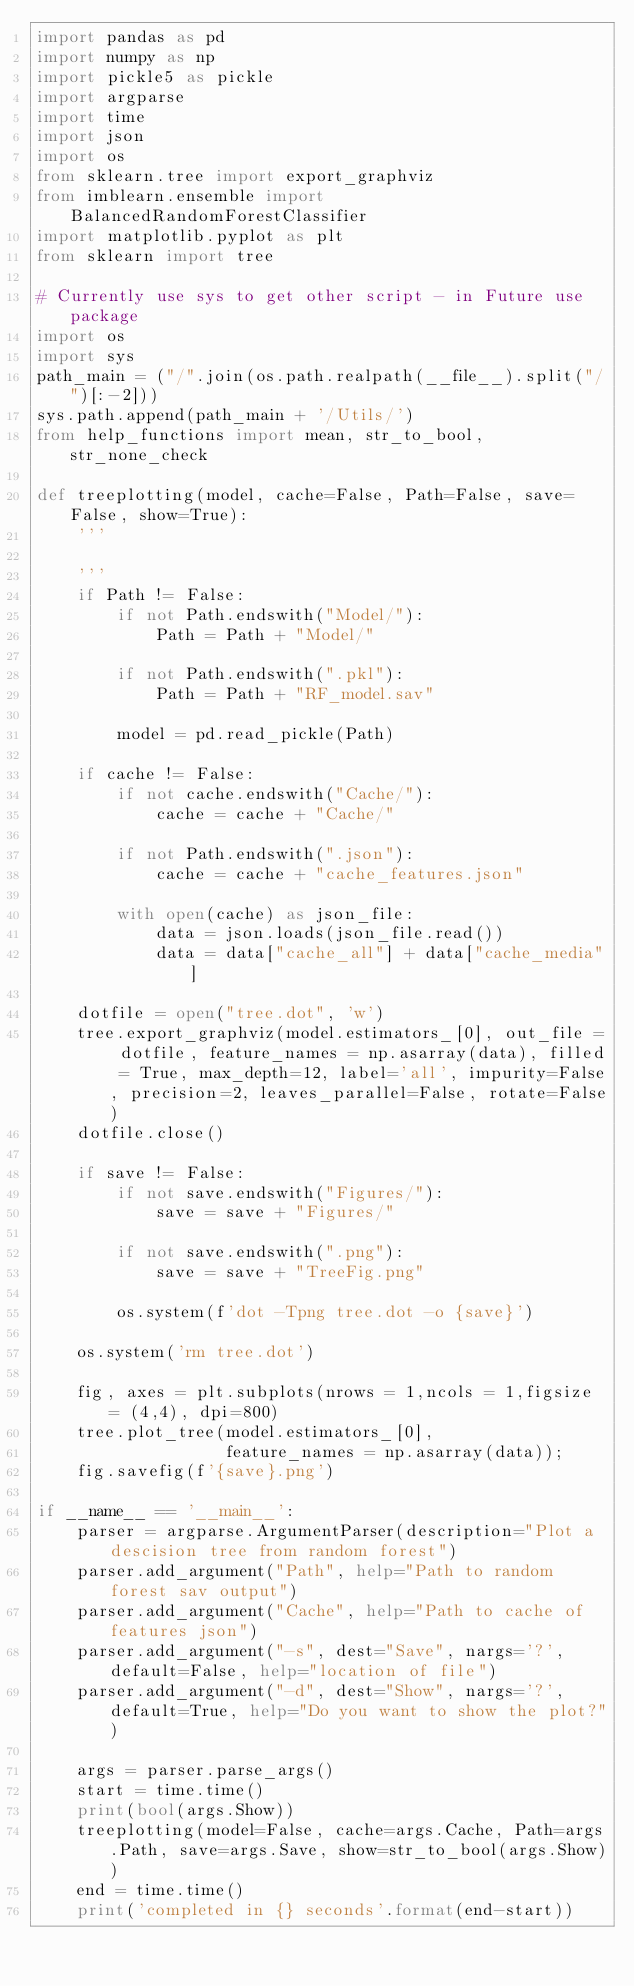<code> <loc_0><loc_0><loc_500><loc_500><_Python_>import pandas as pd
import numpy as np
import pickle5 as pickle
import argparse
import time
import json
import os
from sklearn.tree import export_graphviz
from imblearn.ensemble import BalancedRandomForestClassifier
import matplotlib.pyplot as plt
from sklearn import tree

# Currently use sys to get other script - in Future use package
import os
import sys
path_main = ("/".join(os.path.realpath(__file__).split("/")[:-2]))
sys.path.append(path_main + '/Utils/')
from help_functions import mean, str_to_bool, str_none_check

def treeplotting(model, cache=False, Path=False, save=False, show=True):
    '''

    '''
    if Path != False:
        if not Path.endswith("Model/"):
            Path = Path + "Model/"

        if not Path.endswith(".pkl"):
            Path = Path + "RF_model.sav"
        
        model = pd.read_pickle(Path)

    if cache != False:
        if not cache.endswith("Cache/"):
            cache = cache + "Cache/"

        if not Path.endswith(".json"):
            cache = cache + "cache_features.json"

        with open(cache) as json_file:
            data = json.loads(json_file.read())
            data = data["cache_all"] + data["cache_media"]

    dotfile = open("tree.dot", 'w')
    tree.export_graphviz(model.estimators_[0], out_file = dotfile, feature_names = np.asarray(data), filled = True, max_depth=12, label='all', impurity=False, precision=2, leaves_parallel=False, rotate=False)
    dotfile.close()

    if save != False:
        if not save.endswith("Figures/"):
            save = save + "Figures/"

        if not save.endswith(".png"):
            save = save + "TreeFig.png"

        os.system(f'dot -Tpng tree.dot -o {save}')

    os.system('rm tree.dot')

    fig, axes = plt.subplots(nrows = 1,ncols = 1,figsize = (4,4), dpi=800)
    tree.plot_tree(model.estimators_[0],
                   feature_names = np.asarray(data));
    fig.savefig(f'{save}.png')

if __name__ == '__main__':
    parser = argparse.ArgumentParser(description="Plot a descision tree from random forest")
    parser.add_argument("Path", help="Path to random forest sav output")
    parser.add_argument("Cache", help="Path to cache of features json")
    parser.add_argument("-s", dest="Save", nargs='?', default=False, help="location of file")
    parser.add_argument("-d", dest="Show", nargs='?', default=True, help="Do you want to show the plot?")

    args = parser.parse_args()
    start = time.time()
    print(bool(args.Show))
    treeplotting(model=False, cache=args.Cache, Path=args.Path, save=args.Save, show=str_to_bool(args.Show))
    end = time.time()
    print('completed in {} seconds'.format(end-start))</code> 